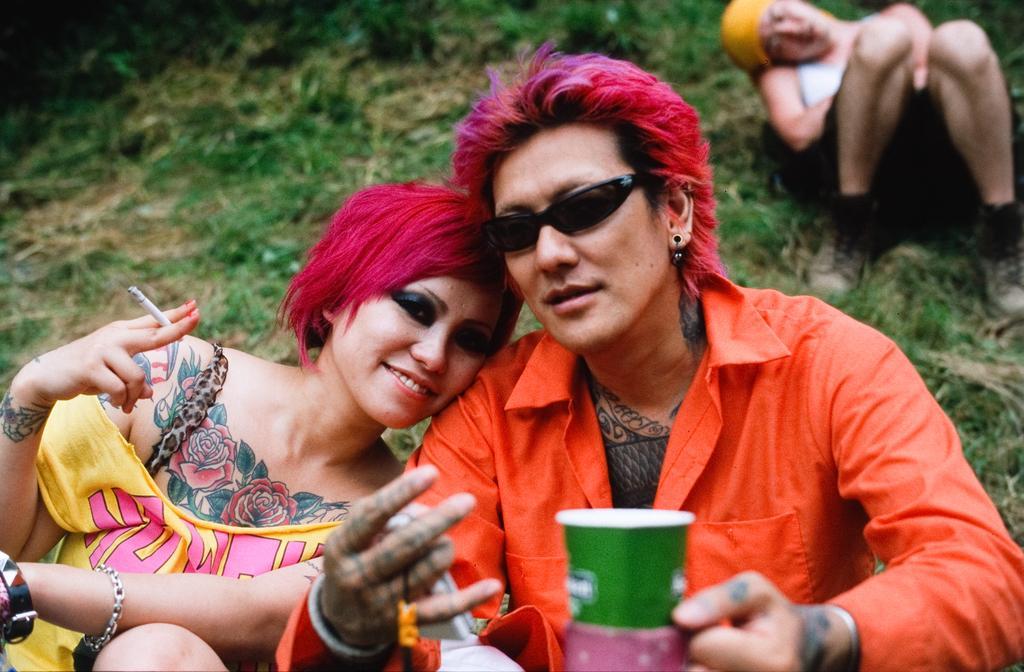Can you describe this image briefly? In this image I can see a man is holding the cup, he wore orange color shirt, beside him a woman is holding the cigarette in her hand. She wore yellow color top, behind them there is the grass. On the right side there is another person lying on the grass. 